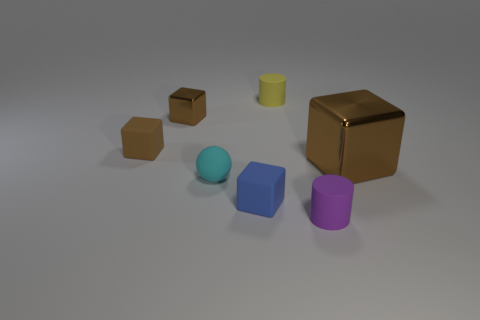Does the big shiny object have the same color as the tiny metal cube?
Keep it short and to the point. Yes. The metallic cube that is the same color as the tiny shiny object is what size?
Keep it short and to the point. Large. There is a cube on the left side of the metallic cube that is to the left of the large block behind the purple matte cylinder; what color is it?
Offer a very short reply. Brown. What number of cyan objects are either rubber cylinders or rubber things?
Offer a very short reply. 1. How many blue matte things are the same shape as the yellow rubber thing?
Offer a very short reply. 0. What is the shape of the other metallic object that is the same size as the blue object?
Provide a short and direct response. Cube. There is a large brown metallic thing; are there any tiny metal cubes behind it?
Offer a very short reply. Yes. Are there any tiny yellow rubber objects on the right side of the tiny cylinder in front of the large brown object?
Your answer should be very brief. No. Is the number of tiny blue matte blocks behind the tiny metallic cube less than the number of small cyan rubber objects behind the yellow cylinder?
Keep it short and to the point. No. Is there any other thing that is the same size as the brown rubber thing?
Your answer should be compact. Yes. 